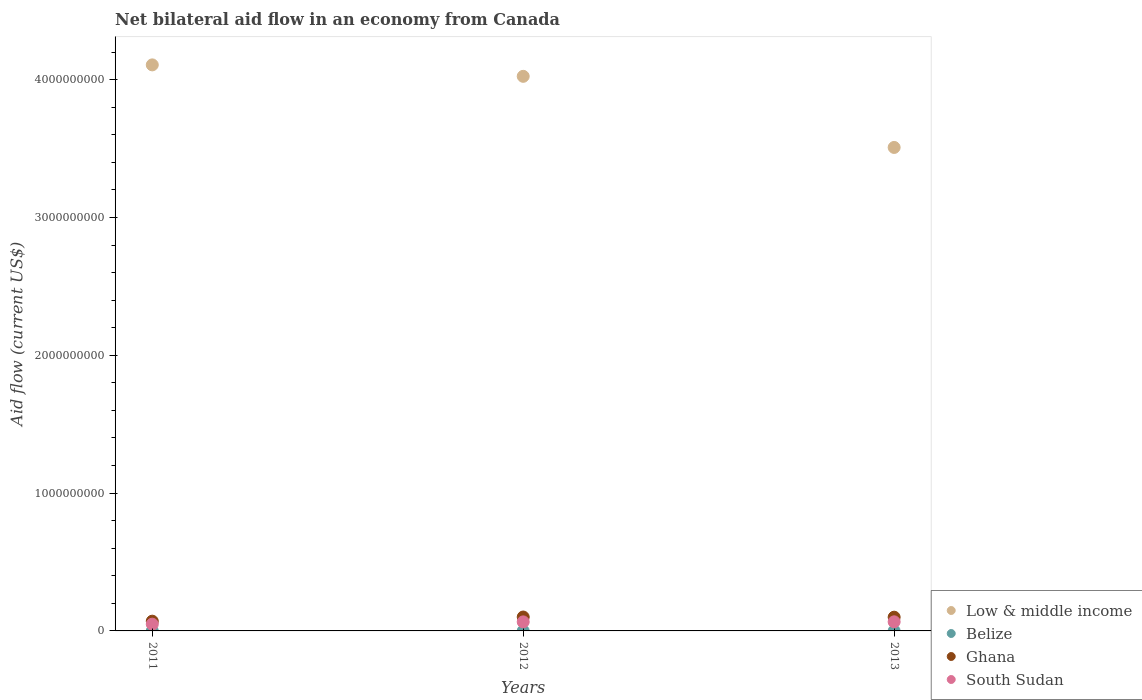Is the number of dotlines equal to the number of legend labels?
Keep it short and to the point. Yes. What is the net bilateral aid flow in Belize in 2012?
Your response must be concise. 2.40e+05. Across all years, what is the maximum net bilateral aid flow in Low & middle income?
Give a very brief answer. 4.11e+09. Across all years, what is the minimum net bilateral aid flow in South Sudan?
Offer a very short reply. 4.90e+07. What is the total net bilateral aid flow in South Sudan in the graph?
Give a very brief answer. 1.81e+08. What is the difference between the net bilateral aid flow in Low & middle income in 2012 and that in 2013?
Offer a very short reply. 5.16e+08. What is the difference between the net bilateral aid flow in Ghana in 2011 and the net bilateral aid flow in Low & middle income in 2013?
Your answer should be very brief. -3.44e+09. What is the average net bilateral aid flow in South Sudan per year?
Offer a very short reply. 6.02e+07. In the year 2013, what is the difference between the net bilateral aid flow in Ghana and net bilateral aid flow in Low & middle income?
Your answer should be very brief. -3.41e+09. In how many years, is the net bilateral aid flow in Low & middle income greater than 2000000000 US$?
Offer a terse response. 3. What is the ratio of the net bilateral aid flow in South Sudan in 2012 to that in 2013?
Provide a succinct answer. 0.99. Is the net bilateral aid flow in Low & middle income in 2011 less than that in 2012?
Offer a very short reply. No. What is the difference between the highest and the second highest net bilateral aid flow in Ghana?
Offer a terse response. 1.15e+06. What is the difference between the highest and the lowest net bilateral aid flow in Low & middle income?
Keep it short and to the point. 5.99e+08. Is it the case that in every year, the sum of the net bilateral aid flow in Belize and net bilateral aid flow in Low & middle income  is greater than the sum of net bilateral aid flow in South Sudan and net bilateral aid flow in Ghana?
Offer a very short reply. No. Does the net bilateral aid flow in Belize monotonically increase over the years?
Provide a short and direct response. No. Is the net bilateral aid flow in Ghana strictly less than the net bilateral aid flow in Belize over the years?
Make the answer very short. No. Does the graph contain any zero values?
Offer a terse response. No. Does the graph contain grids?
Make the answer very short. No. How are the legend labels stacked?
Provide a short and direct response. Vertical. What is the title of the graph?
Your response must be concise. Net bilateral aid flow in an economy from Canada. Does "Korea (Democratic)" appear as one of the legend labels in the graph?
Provide a short and direct response. No. What is the label or title of the X-axis?
Ensure brevity in your answer.  Years. What is the label or title of the Y-axis?
Make the answer very short. Aid flow (current US$). What is the Aid flow (current US$) of Low & middle income in 2011?
Make the answer very short. 4.11e+09. What is the Aid flow (current US$) in Ghana in 2011?
Make the answer very short. 7.07e+07. What is the Aid flow (current US$) of South Sudan in 2011?
Offer a very short reply. 4.90e+07. What is the Aid flow (current US$) in Low & middle income in 2012?
Make the answer very short. 4.02e+09. What is the Aid flow (current US$) of Ghana in 2012?
Provide a succinct answer. 1.01e+08. What is the Aid flow (current US$) of South Sudan in 2012?
Offer a very short reply. 6.56e+07. What is the Aid flow (current US$) of Low & middle income in 2013?
Offer a very short reply. 3.51e+09. What is the Aid flow (current US$) of Belize in 2013?
Make the answer very short. 1.50e+05. What is the Aid flow (current US$) of Ghana in 2013?
Offer a very short reply. 9.97e+07. What is the Aid flow (current US$) in South Sudan in 2013?
Your answer should be very brief. 6.60e+07. Across all years, what is the maximum Aid flow (current US$) of Low & middle income?
Your response must be concise. 4.11e+09. Across all years, what is the maximum Aid flow (current US$) in Ghana?
Provide a succinct answer. 1.01e+08. Across all years, what is the maximum Aid flow (current US$) in South Sudan?
Your answer should be compact. 6.60e+07. Across all years, what is the minimum Aid flow (current US$) in Low & middle income?
Offer a very short reply. 3.51e+09. Across all years, what is the minimum Aid flow (current US$) of Belize?
Provide a short and direct response. 1.10e+05. Across all years, what is the minimum Aid flow (current US$) of Ghana?
Your answer should be compact. 7.07e+07. Across all years, what is the minimum Aid flow (current US$) of South Sudan?
Your response must be concise. 4.90e+07. What is the total Aid flow (current US$) in Low & middle income in the graph?
Make the answer very short. 1.16e+1. What is the total Aid flow (current US$) in Belize in the graph?
Your response must be concise. 5.00e+05. What is the total Aid flow (current US$) in Ghana in the graph?
Make the answer very short. 2.71e+08. What is the total Aid flow (current US$) in South Sudan in the graph?
Your response must be concise. 1.81e+08. What is the difference between the Aid flow (current US$) in Low & middle income in 2011 and that in 2012?
Make the answer very short. 8.31e+07. What is the difference between the Aid flow (current US$) of Ghana in 2011 and that in 2012?
Offer a very short reply. -3.02e+07. What is the difference between the Aid flow (current US$) in South Sudan in 2011 and that in 2012?
Offer a terse response. -1.66e+07. What is the difference between the Aid flow (current US$) in Low & middle income in 2011 and that in 2013?
Provide a short and direct response. 5.99e+08. What is the difference between the Aid flow (current US$) in Ghana in 2011 and that in 2013?
Keep it short and to the point. -2.90e+07. What is the difference between the Aid flow (current US$) in South Sudan in 2011 and that in 2013?
Give a very brief answer. -1.71e+07. What is the difference between the Aid flow (current US$) of Low & middle income in 2012 and that in 2013?
Keep it short and to the point. 5.16e+08. What is the difference between the Aid flow (current US$) of Belize in 2012 and that in 2013?
Your answer should be very brief. 9.00e+04. What is the difference between the Aid flow (current US$) of Ghana in 2012 and that in 2013?
Provide a short and direct response. 1.15e+06. What is the difference between the Aid flow (current US$) in South Sudan in 2012 and that in 2013?
Offer a very short reply. -5.00e+05. What is the difference between the Aid flow (current US$) of Low & middle income in 2011 and the Aid flow (current US$) of Belize in 2012?
Give a very brief answer. 4.11e+09. What is the difference between the Aid flow (current US$) in Low & middle income in 2011 and the Aid flow (current US$) in Ghana in 2012?
Keep it short and to the point. 4.01e+09. What is the difference between the Aid flow (current US$) of Low & middle income in 2011 and the Aid flow (current US$) of South Sudan in 2012?
Provide a short and direct response. 4.04e+09. What is the difference between the Aid flow (current US$) in Belize in 2011 and the Aid flow (current US$) in Ghana in 2012?
Make the answer very short. -1.01e+08. What is the difference between the Aid flow (current US$) in Belize in 2011 and the Aid flow (current US$) in South Sudan in 2012?
Ensure brevity in your answer.  -6.54e+07. What is the difference between the Aid flow (current US$) in Ghana in 2011 and the Aid flow (current US$) in South Sudan in 2012?
Give a very brief answer. 5.17e+06. What is the difference between the Aid flow (current US$) of Low & middle income in 2011 and the Aid flow (current US$) of Belize in 2013?
Offer a very short reply. 4.11e+09. What is the difference between the Aid flow (current US$) of Low & middle income in 2011 and the Aid flow (current US$) of Ghana in 2013?
Provide a succinct answer. 4.01e+09. What is the difference between the Aid flow (current US$) in Low & middle income in 2011 and the Aid flow (current US$) in South Sudan in 2013?
Ensure brevity in your answer.  4.04e+09. What is the difference between the Aid flow (current US$) of Belize in 2011 and the Aid flow (current US$) of Ghana in 2013?
Your answer should be compact. -9.96e+07. What is the difference between the Aid flow (current US$) in Belize in 2011 and the Aid flow (current US$) in South Sudan in 2013?
Offer a terse response. -6.59e+07. What is the difference between the Aid flow (current US$) of Ghana in 2011 and the Aid flow (current US$) of South Sudan in 2013?
Give a very brief answer. 4.67e+06. What is the difference between the Aid flow (current US$) in Low & middle income in 2012 and the Aid flow (current US$) in Belize in 2013?
Your response must be concise. 4.02e+09. What is the difference between the Aid flow (current US$) of Low & middle income in 2012 and the Aid flow (current US$) of Ghana in 2013?
Keep it short and to the point. 3.92e+09. What is the difference between the Aid flow (current US$) of Low & middle income in 2012 and the Aid flow (current US$) of South Sudan in 2013?
Provide a short and direct response. 3.96e+09. What is the difference between the Aid flow (current US$) in Belize in 2012 and the Aid flow (current US$) in Ghana in 2013?
Ensure brevity in your answer.  -9.95e+07. What is the difference between the Aid flow (current US$) of Belize in 2012 and the Aid flow (current US$) of South Sudan in 2013?
Keep it short and to the point. -6.58e+07. What is the difference between the Aid flow (current US$) of Ghana in 2012 and the Aid flow (current US$) of South Sudan in 2013?
Offer a terse response. 3.48e+07. What is the average Aid flow (current US$) of Low & middle income per year?
Provide a short and direct response. 3.88e+09. What is the average Aid flow (current US$) of Belize per year?
Provide a succinct answer. 1.67e+05. What is the average Aid flow (current US$) of Ghana per year?
Your answer should be compact. 9.04e+07. What is the average Aid flow (current US$) in South Sudan per year?
Make the answer very short. 6.02e+07. In the year 2011, what is the difference between the Aid flow (current US$) of Low & middle income and Aid flow (current US$) of Belize?
Offer a very short reply. 4.11e+09. In the year 2011, what is the difference between the Aid flow (current US$) in Low & middle income and Aid flow (current US$) in Ghana?
Provide a succinct answer. 4.04e+09. In the year 2011, what is the difference between the Aid flow (current US$) in Low & middle income and Aid flow (current US$) in South Sudan?
Keep it short and to the point. 4.06e+09. In the year 2011, what is the difference between the Aid flow (current US$) in Belize and Aid flow (current US$) in Ghana?
Provide a succinct answer. -7.06e+07. In the year 2011, what is the difference between the Aid flow (current US$) of Belize and Aid flow (current US$) of South Sudan?
Offer a very short reply. -4.88e+07. In the year 2011, what is the difference between the Aid flow (current US$) in Ghana and Aid flow (current US$) in South Sudan?
Provide a succinct answer. 2.18e+07. In the year 2012, what is the difference between the Aid flow (current US$) in Low & middle income and Aid flow (current US$) in Belize?
Ensure brevity in your answer.  4.02e+09. In the year 2012, what is the difference between the Aid flow (current US$) in Low & middle income and Aid flow (current US$) in Ghana?
Offer a very short reply. 3.92e+09. In the year 2012, what is the difference between the Aid flow (current US$) of Low & middle income and Aid flow (current US$) of South Sudan?
Offer a terse response. 3.96e+09. In the year 2012, what is the difference between the Aid flow (current US$) of Belize and Aid flow (current US$) of Ghana?
Ensure brevity in your answer.  -1.01e+08. In the year 2012, what is the difference between the Aid flow (current US$) in Belize and Aid flow (current US$) in South Sudan?
Give a very brief answer. -6.53e+07. In the year 2012, what is the difference between the Aid flow (current US$) in Ghana and Aid flow (current US$) in South Sudan?
Give a very brief answer. 3.53e+07. In the year 2013, what is the difference between the Aid flow (current US$) of Low & middle income and Aid flow (current US$) of Belize?
Give a very brief answer. 3.51e+09. In the year 2013, what is the difference between the Aid flow (current US$) in Low & middle income and Aid flow (current US$) in Ghana?
Provide a succinct answer. 3.41e+09. In the year 2013, what is the difference between the Aid flow (current US$) of Low & middle income and Aid flow (current US$) of South Sudan?
Your response must be concise. 3.44e+09. In the year 2013, what is the difference between the Aid flow (current US$) in Belize and Aid flow (current US$) in Ghana?
Keep it short and to the point. -9.96e+07. In the year 2013, what is the difference between the Aid flow (current US$) in Belize and Aid flow (current US$) in South Sudan?
Give a very brief answer. -6.59e+07. In the year 2013, what is the difference between the Aid flow (current US$) of Ghana and Aid flow (current US$) of South Sudan?
Give a very brief answer. 3.37e+07. What is the ratio of the Aid flow (current US$) of Low & middle income in 2011 to that in 2012?
Your answer should be very brief. 1.02. What is the ratio of the Aid flow (current US$) in Belize in 2011 to that in 2012?
Keep it short and to the point. 0.46. What is the ratio of the Aid flow (current US$) of Ghana in 2011 to that in 2012?
Your answer should be compact. 0.7. What is the ratio of the Aid flow (current US$) of South Sudan in 2011 to that in 2012?
Your answer should be compact. 0.75. What is the ratio of the Aid flow (current US$) of Low & middle income in 2011 to that in 2013?
Offer a very short reply. 1.17. What is the ratio of the Aid flow (current US$) in Belize in 2011 to that in 2013?
Your response must be concise. 0.73. What is the ratio of the Aid flow (current US$) of Ghana in 2011 to that in 2013?
Give a very brief answer. 0.71. What is the ratio of the Aid flow (current US$) in South Sudan in 2011 to that in 2013?
Make the answer very short. 0.74. What is the ratio of the Aid flow (current US$) in Low & middle income in 2012 to that in 2013?
Your answer should be compact. 1.15. What is the ratio of the Aid flow (current US$) of Ghana in 2012 to that in 2013?
Make the answer very short. 1.01. What is the difference between the highest and the second highest Aid flow (current US$) in Low & middle income?
Provide a short and direct response. 8.31e+07. What is the difference between the highest and the second highest Aid flow (current US$) in Belize?
Provide a short and direct response. 9.00e+04. What is the difference between the highest and the second highest Aid flow (current US$) in Ghana?
Your answer should be compact. 1.15e+06. What is the difference between the highest and the second highest Aid flow (current US$) of South Sudan?
Your answer should be very brief. 5.00e+05. What is the difference between the highest and the lowest Aid flow (current US$) in Low & middle income?
Your answer should be compact. 5.99e+08. What is the difference between the highest and the lowest Aid flow (current US$) of Belize?
Your response must be concise. 1.30e+05. What is the difference between the highest and the lowest Aid flow (current US$) in Ghana?
Keep it short and to the point. 3.02e+07. What is the difference between the highest and the lowest Aid flow (current US$) in South Sudan?
Ensure brevity in your answer.  1.71e+07. 